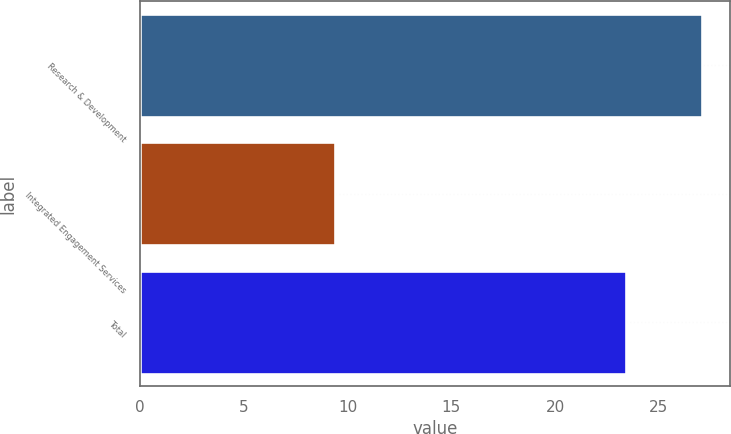Convert chart. <chart><loc_0><loc_0><loc_500><loc_500><bar_chart><fcel>Research & Development<fcel>Integrated Engagement Services<fcel>Total<nl><fcel>27.1<fcel>9.4<fcel>23.4<nl></chart> 